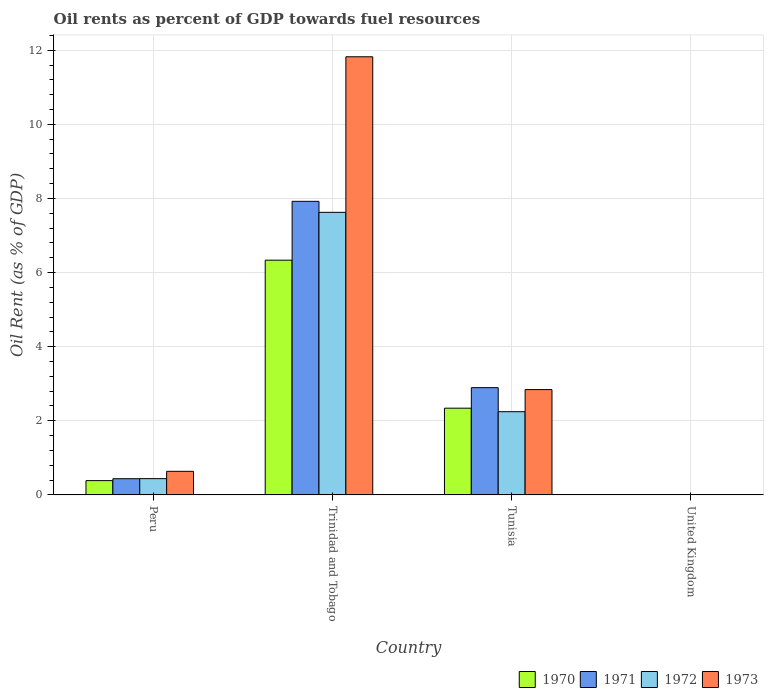How many groups of bars are there?
Offer a terse response. 4. How many bars are there on the 4th tick from the left?
Ensure brevity in your answer.  4. In how many cases, is the number of bars for a given country not equal to the number of legend labels?
Offer a very short reply. 0. What is the oil rent in 1970 in United Kingdom?
Your response must be concise. 0. Across all countries, what is the maximum oil rent in 1973?
Provide a short and direct response. 11.82. Across all countries, what is the minimum oil rent in 1971?
Give a very brief answer. 0. In which country was the oil rent in 1970 maximum?
Your response must be concise. Trinidad and Tobago. In which country was the oil rent in 1970 minimum?
Provide a short and direct response. United Kingdom. What is the total oil rent in 1973 in the graph?
Ensure brevity in your answer.  15.3. What is the difference between the oil rent in 1972 in Peru and that in United Kingdom?
Keep it short and to the point. 0.44. What is the difference between the oil rent in 1973 in Tunisia and the oil rent in 1972 in United Kingdom?
Give a very brief answer. 2.84. What is the average oil rent in 1973 per country?
Your response must be concise. 3.83. What is the difference between the oil rent of/in 1970 and oil rent of/in 1972 in United Kingdom?
Your answer should be compact. -0. What is the ratio of the oil rent in 1973 in Tunisia to that in United Kingdom?
Provide a short and direct response. 1266.39. What is the difference between the highest and the second highest oil rent in 1971?
Offer a terse response. -2.46. What is the difference between the highest and the lowest oil rent in 1972?
Your response must be concise. 7.62. In how many countries, is the oil rent in 1971 greater than the average oil rent in 1971 taken over all countries?
Give a very brief answer. 2. Is the sum of the oil rent in 1971 in Tunisia and United Kingdom greater than the maximum oil rent in 1970 across all countries?
Provide a short and direct response. No. Are all the bars in the graph horizontal?
Provide a short and direct response. No. How many countries are there in the graph?
Provide a succinct answer. 4. What is the difference between two consecutive major ticks on the Y-axis?
Make the answer very short. 2. Are the values on the major ticks of Y-axis written in scientific E-notation?
Provide a succinct answer. No. Does the graph contain any zero values?
Your response must be concise. No. What is the title of the graph?
Make the answer very short. Oil rents as percent of GDP towards fuel resources. What is the label or title of the Y-axis?
Your response must be concise. Oil Rent (as % of GDP). What is the Oil Rent (as % of GDP) in 1970 in Peru?
Keep it short and to the point. 0.39. What is the Oil Rent (as % of GDP) of 1971 in Peru?
Your response must be concise. 0.44. What is the Oil Rent (as % of GDP) of 1972 in Peru?
Offer a very short reply. 0.44. What is the Oil Rent (as % of GDP) in 1973 in Peru?
Make the answer very short. 0.64. What is the Oil Rent (as % of GDP) of 1970 in Trinidad and Tobago?
Provide a succinct answer. 6.33. What is the Oil Rent (as % of GDP) in 1971 in Trinidad and Tobago?
Keep it short and to the point. 7.92. What is the Oil Rent (as % of GDP) in 1972 in Trinidad and Tobago?
Provide a short and direct response. 7.63. What is the Oil Rent (as % of GDP) of 1973 in Trinidad and Tobago?
Keep it short and to the point. 11.82. What is the Oil Rent (as % of GDP) of 1970 in Tunisia?
Offer a very short reply. 2.34. What is the Oil Rent (as % of GDP) in 1971 in Tunisia?
Offer a terse response. 2.89. What is the Oil Rent (as % of GDP) in 1972 in Tunisia?
Offer a very short reply. 2.25. What is the Oil Rent (as % of GDP) in 1973 in Tunisia?
Keep it short and to the point. 2.84. What is the Oil Rent (as % of GDP) in 1970 in United Kingdom?
Keep it short and to the point. 0. What is the Oil Rent (as % of GDP) in 1971 in United Kingdom?
Your response must be concise. 0. What is the Oil Rent (as % of GDP) in 1972 in United Kingdom?
Ensure brevity in your answer.  0. What is the Oil Rent (as % of GDP) in 1973 in United Kingdom?
Your answer should be compact. 0. Across all countries, what is the maximum Oil Rent (as % of GDP) in 1970?
Your answer should be very brief. 6.33. Across all countries, what is the maximum Oil Rent (as % of GDP) in 1971?
Keep it short and to the point. 7.92. Across all countries, what is the maximum Oil Rent (as % of GDP) in 1972?
Offer a terse response. 7.63. Across all countries, what is the maximum Oil Rent (as % of GDP) of 1973?
Your answer should be very brief. 11.82. Across all countries, what is the minimum Oil Rent (as % of GDP) in 1970?
Keep it short and to the point. 0. Across all countries, what is the minimum Oil Rent (as % of GDP) of 1971?
Provide a short and direct response. 0. Across all countries, what is the minimum Oil Rent (as % of GDP) of 1972?
Offer a terse response. 0. Across all countries, what is the minimum Oil Rent (as % of GDP) of 1973?
Your answer should be very brief. 0. What is the total Oil Rent (as % of GDP) of 1970 in the graph?
Keep it short and to the point. 9.06. What is the total Oil Rent (as % of GDP) of 1971 in the graph?
Keep it short and to the point. 11.25. What is the total Oil Rent (as % of GDP) in 1972 in the graph?
Ensure brevity in your answer.  10.31. What is the total Oil Rent (as % of GDP) of 1973 in the graph?
Your answer should be very brief. 15.3. What is the difference between the Oil Rent (as % of GDP) of 1970 in Peru and that in Trinidad and Tobago?
Offer a terse response. -5.95. What is the difference between the Oil Rent (as % of GDP) of 1971 in Peru and that in Trinidad and Tobago?
Keep it short and to the point. -7.49. What is the difference between the Oil Rent (as % of GDP) of 1972 in Peru and that in Trinidad and Tobago?
Offer a very short reply. -7.19. What is the difference between the Oil Rent (as % of GDP) of 1973 in Peru and that in Trinidad and Tobago?
Provide a short and direct response. -11.19. What is the difference between the Oil Rent (as % of GDP) in 1970 in Peru and that in Tunisia?
Offer a very short reply. -1.95. What is the difference between the Oil Rent (as % of GDP) of 1971 in Peru and that in Tunisia?
Provide a short and direct response. -2.46. What is the difference between the Oil Rent (as % of GDP) in 1972 in Peru and that in Tunisia?
Give a very brief answer. -1.81. What is the difference between the Oil Rent (as % of GDP) in 1973 in Peru and that in Tunisia?
Your response must be concise. -2.21. What is the difference between the Oil Rent (as % of GDP) of 1970 in Peru and that in United Kingdom?
Make the answer very short. 0.38. What is the difference between the Oil Rent (as % of GDP) in 1971 in Peru and that in United Kingdom?
Offer a terse response. 0.44. What is the difference between the Oil Rent (as % of GDP) in 1972 in Peru and that in United Kingdom?
Provide a short and direct response. 0.44. What is the difference between the Oil Rent (as % of GDP) of 1973 in Peru and that in United Kingdom?
Make the answer very short. 0.63. What is the difference between the Oil Rent (as % of GDP) in 1970 in Trinidad and Tobago and that in Tunisia?
Offer a very short reply. 3.99. What is the difference between the Oil Rent (as % of GDP) in 1971 in Trinidad and Tobago and that in Tunisia?
Make the answer very short. 5.03. What is the difference between the Oil Rent (as % of GDP) of 1972 in Trinidad and Tobago and that in Tunisia?
Your answer should be very brief. 5.38. What is the difference between the Oil Rent (as % of GDP) in 1973 in Trinidad and Tobago and that in Tunisia?
Provide a short and direct response. 8.98. What is the difference between the Oil Rent (as % of GDP) in 1970 in Trinidad and Tobago and that in United Kingdom?
Your answer should be very brief. 6.33. What is the difference between the Oil Rent (as % of GDP) of 1971 in Trinidad and Tobago and that in United Kingdom?
Keep it short and to the point. 7.92. What is the difference between the Oil Rent (as % of GDP) in 1972 in Trinidad and Tobago and that in United Kingdom?
Make the answer very short. 7.62. What is the difference between the Oil Rent (as % of GDP) of 1973 in Trinidad and Tobago and that in United Kingdom?
Your answer should be compact. 11.82. What is the difference between the Oil Rent (as % of GDP) of 1970 in Tunisia and that in United Kingdom?
Offer a very short reply. 2.34. What is the difference between the Oil Rent (as % of GDP) of 1971 in Tunisia and that in United Kingdom?
Your response must be concise. 2.89. What is the difference between the Oil Rent (as % of GDP) in 1972 in Tunisia and that in United Kingdom?
Give a very brief answer. 2.24. What is the difference between the Oil Rent (as % of GDP) in 1973 in Tunisia and that in United Kingdom?
Your answer should be compact. 2.84. What is the difference between the Oil Rent (as % of GDP) in 1970 in Peru and the Oil Rent (as % of GDP) in 1971 in Trinidad and Tobago?
Your answer should be compact. -7.54. What is the difference between the Oil Rent (as % of GDP) in 1970 in Peru and the Oil Rent (as % of GDP) in 1972 in Trinidad and Tobago?
Offer a very short reply. -7.24. What is the difference between the Oil Rent (as % of GDP) in 1970 in Peru and the Oil Rent (as % of GDP) in 1973 in Trinidad and Tobago?
Ensure brevity in your answer.  -11.44. What is the difference between the Oil Rent (as % of GDP) of 1971 in Peru and the Oil Rent (as % of GDP) of 1972 in Trinidad and Tobago?
Your answer should be compact. -7.19. What is the difference between the Oil Rent (as % of GDP) in 1971 in Peru and the Oil Rent (as % of GDP) in 1973 in Trinidad and Tobago?
Give a very brief answer. -11.39. What is the difference between the Oil Rent (as % of GDP) of 1972 in Peru and the Oil Rent (as % of GDP) of 1973 in Trinidad and Tobago?
Your answer should be very brief. -11.38. What is the difference between the Oil Rent (as % of GDP) of 1970 in Peru and the Oil Rent (as % of GDP) of 1971 in Tunisia?
Your response must be concise. -2.51. What is the difference between the Oil Rent (as % of GDP) of 1970 in Peru and the Oil Rent (as % of GDP) of 1972 in Tunisia?
Your answer should be very brief. -1.86. What is the difference between the Oil Rent (as % of GDP) of 1970 in Peru and the Oil Rent (as % of GDP) of 1973 in Tunisia?
Your answer should be very brief. -2.46. What is the difference between the Oil Rent (as % of GDP) in 1971 in Peru and the Oil Rent (as % of GDP) in 1972 in Tunisia?
Offer a very short reply. -1.81. What is the difference between the Oil Rent (as % of GDP) in 1971 in Peru and the Oil Rent (as % of GDP) in 1973 in Tunisia?
Offer a terse response. -2.4. What is the difference between the Oil Rent (as % of GDP) of 1972 in Peru and the Oil Rent (as % of GDP) of 1973 in Tunisia?
Offer a very short reply. -2.4. What is the difference between the Oil Rent (as % of GDP) in 1970 in Peru and the Oil Rent (as % of GDP) in 1971 in United Kingdom?
Provide a succinct answer. 0.38. What is the difference between the Oil Rent (as % of GDP) in 1970 in Peru and the Oil Rent (as % of GDP) in 1972 in United Kingdom?
Make the answer very short. 0.38. What is the difference between the Oil Rent (as % of GDP) in 1970 in Peru and the Oil Rent (as % of GDP) in 1973 in United Kingdom?
Make the answer very short. 0.38. What is the difference between the Oil Rent (as % of GDP) in 1971 in Peru and the Oil Rent (as % of GDP) in 1972 in United Kingdom?
Offer a very short reply. 0.44. What is the difference between the Oil Rent (as % of GDP) in 1971 in Peru and the Oil Rent (as % of GDP) in 1973 in United Kingdom?
Offer a very short reply. 0.43. What is the difference between the Oil Rent (as % of GDP) of 1972 in Peru and the Oil Rent (as % of GDP) of 1973 in United Kingdom?
Keep it short and to the point. 0.44. What is the difference between the Oil Rent (as % of GDP) in 1970 in Trinidad and Tobago and the Oil Rent (as % of GDP) in 1971 in Tunisia?
Give a very brief answer. 3.44. What is the difference between the Oil Rent (as % of GDP) in 1970 in Trinidad and Tobago and the Oil Rent (as % of GDP) in 1972 in Tunisia?
Provide a succinct answer. 4.09. What is the difference between the Oil Rent (as % of GDP) in 1970 in Trinidad and Tobago and the Oil Rent (as % of GDP) in 1973 in Tunisia?
Your answer should be very brief. 3.49. What is the difference between the Oil Rent (as % of GDP) of 1971 in Trinidad and Tobago and the Oil Rent (as % of GDP) of 1972 in Tunisia?
Offer a terse response. 5.68. What is the difference between the Oil Rent (as % of GDP) of 1971 in Trinidad and Tobago and the Oil Rent (as % of GDP) of 1973 in Tunisia?
Make the answer very short. 5.08. What is the difference between the Oil Rent (as % of GDP) of 1972 in Trinidad and Tobago and the Oil Rent (as % of GDP) of 1973 in Tunisia?
Your response must be concise. 4.78. What is the difference between the Oil Rent (as % of GDP) in 1970 in Trinidad and Tobago and the Oil Rent (as % of GDP) in 1971 in United Kingdom?
Your answer should be compact. 6.33. What is the difference between the Oil Rent (as % of GDP) of 1970 in Trinidad and Tobago and the Oil Rent (as % of GDP) of 1972 in United Kingdom?
Offer a terse response. 6.33. What is the difference between the Oil Rent (as % of GDP) in 1970 in Trinidad and Tobago and the Oil Rent (as % of GDP) in 1973 in United Kingdom?
Your answer should be compact. 6.33. What is the difference between the Oil Rent (as % of GDP) of 1971 in Trinidad and Tobago and the Oil Rent (as % of GDP) of 1972 in United Kingdom?
Keep it short and to the point. 7.92. What is the difference between the Oil Rent (as % of GDP) in 1971 in Trinidad and Tobago and the Oil Rent (as % of GDP) in 1973 in United Kingdom?
Make the answer very short. 7.92. What is the difference between the Oil Rent (as % of GDP) in 1972 in Trinidad and Tobago and the Oil Rent (as % of GDP) in 1973 in United Kingdom?
Provide a succinct answer. 7.62. What is the difference between the Oil Rent (as % of GDP) in 1970 in Tunisia and the Oil Rent (as % of GDP) in 1971 in United Kingdom?
Provide a succinct answer. 2.34. What is the difference between the Oil Rent (as % of GDP) in 1970 in Tunisia and the Oil Rent (as % of GDP) in 1972 in United Kingdom?
Ensure brevity in your answer.  2.34. What is the difference between the Oil Rent (as % of GDP) in 1970 in Tunisia and the Oil Rent (as % of GDP) in 1973 in United Kingdom?
Make the answer very short. 2.34. What is the difference between the Oil Rent (as % of GDP) in 1971 in Tunisia and the Oil Rent (as % of GDP) in 1972 in United Kingdom?
Your answer should be compact. 2.89. What is the difference between the Oil Rent (as % of GDP) in 1971 in Tunisia and the Oil Rent (as % of GDP) in 1973 in United Kingdom?
Offer a very short reply. 2.89. What is the difference between the Oil Rent (as % of GDP) of 1972 in Tunisia and the Oil Rent (as % of GDP) of 1973 in United Kingdom?
Keep it short and to the point. 2.24. What is the average Oil Rent (as % of GDP) in 1970 per country?
Your answer should be compact. 2.27. What is the average Oil Rent (as % of GDP) of 1971 per country?
Your answer should be compact. 2.81. What is the average Oil Rent (as % of GDP) in 1972 per country?
Offer a very short reply. 2.58. What is the average Oil Rent (as % of GDP) in 1973 per country?
Your response must be concise. 3.83. What is the difference between the Oil Rent (as % of GDP) in 1970 and Oil Rent (as % of GDP) in 1971 in Peru?
Ensure brevity in your answer.  -0.05. What is the difference between the Oil Rent (as % of GDP) of 1970 and Oil Rent (as % of GDP) of 1972 in Peru?
Keep it short and to the point. -0.05. What is the difference between the Oil Rent (as % of GDP) in 1970 and Oil Rent (as % of GDP) in 1973 in Peru?
Offer a very short reply. -0.25. What is the difference between the Oil Rent (as % of GDP) in 1971 and Oil Rent (as % of GDP) in 1972 in Peru?
Ensure brevity in your answer.  -0. What is the difference between the Oil Rent (as % of GDP) in 1971 and Oil Rent (as % of GDP) in 1973 in Peru?
Make the answer very short. -0.2. What is the difference between the Oil Rent (as % of GDP) of 1972 and Oil Rent (as % of GDP) of 1973 in Peru?
Make the answer very short. -0.2. What is the difference between the Oil Rent (as % of GDP) in 1970 and Oil Rent (as % of GDP) in 1971 in Trinidad and Tobago?
Keep it short and to the point. -1.59. What is the difference between the Oil Rent (as % of GDP) of 1970 and Oil Rent (as % of GDP) of 1972 in Trinidad and Tobago?
Offer a very short reply. -1.29. What is the difference between the Oil Rent (as % of GDP) in 1970 and Oil Rent (as % of GDP) in 1973 in Trinidad and Tobago?
Provide a short and direct response. -5.49. What is the difference between the Oil Rent (as % of GDP) of 1971 and Oil Rent (as % of GDP) of 1972 in Trinidad and Tobago?
Offer a terse response. 0.3. What is the difference between the Oil Rent (as % of GDP) of 1971 and Oil Rent (as % of GDP) of 1973 in Trinidad and Tobago?
Your answer should be very brief. -3.9. What is the difference between the Oil Rent (as % of GDP) in 1972 and Oil Rent (as % of GDP) in 1973 in Trinidad and Tobago?
Give a very brief answer. -4.2. What is the difference between the Oil Rent (as % of GDP) of 1970 and Oil Rent (as % of GDP) of 1971 in Tunisia?
Your answer should be compact. -0.55. What is the difference between the Oil Rent (as % of GDP) in 1970 and Oil Rent (as % of GDP) in 1972 in Tunisia?
Offer a very short reply. 0.1. What is the difference between the Oil Rent (as % of GDP) in 1970 and Oil Rent (as % of GDP) in 1973 in Tunisia?
Your answer should be very brief. -0.5. What is the difference between the Oil Rent (as % of GDP) of 1971 and Oil Rent (as % of GDP) of 1972 in Tunisia?
Keep it short and to the point. 0.65. What is the difference between the Oil Rent (as % of GDP) of 1971 and Oil Rent (as % of GDP) of 1973 in Tunisia?
Provide a succinct answer. 0.05. What is the difference between the Oil Rent (as % of GDP) in 1972 and Oil Rent (as % of GDP) in 1973 in Tunisia?
Your answer should be very brief. -0.6. What is the difference between the Oil Rent (as % of GDP) in 1970 and Oil Rent (as % of GDP) in 1971 in United Kingdom?
Provide a succinct answer. 0. What is the difference between the Oil Rent (as % of GDP) of 1970 and Oil Rent (as % of GDP) of 1972 in United Kingdom?
Provide a short and direct response. -0. What is the difference between the Oil Rent (as % of GDP) in 1970 and Oil Rent (as % of GDP) in 1973 in United Kingdom?
Your answer should be very brief. -0. What is the difference between the Oil Rent (as % of GDP) in 1971 and Oil Rent (as % of GDP) in 1972 in United Kingdom?
Ensure brevity in your answer.  -0. What is the difference between the Oil Rent (as % of GDP) in 1971 and Oil Rent (as % of GDP) in 1973 in United Kingdom?
Provide a short and direct response. -0. What is the difference between the Oil Rent (as % of GDP) of 1972 and Oil Rent (as % of GDP) of 1973 in United Kingdom?
Make the answer very short. -0. What is the ratio of the Oil Rent (as % of GDP) of 1970 in Peru to that in Trinidad and Tobago?
Make the answer very short. 0.06. What is the ratio of the Oil Rent (as % of GDP) of 1971 in Peru to that in Trinidad and Tobago?
Your response must be concise. 0.06. What is the ratio of the Oil Rent (as % of GDP) in 1972 in Peru to that in Trinidad and Tobago?
Your response must be concise. 0.06. What is the ratio of the Oil Rent (as % of GDP) of 1973 in Peru to that in Trinidad and Tobago?
Offer a very short reply. 0.05. What is the ratio of the Oil Rent (as % of GDP) of 1970 in Peru to that in Tunisia?
Make the answer very short. 0.16. What is the ratio of the Oil Rent (as % of GDP) in 1971 in Peru to that in Tunisia?
Your response must be concise. 0.15. What is the ratio of the Oil Rent (as % of GDP) of 1972 in Peru to that in Tunisia?
Offer a terse response. 0.2. What is the ratio of the Oil Rent (as % of GDP) in 1973 in Peru to that in Tunisia?
Make the answer very short. 0.22. What is the ratio of the Oil Rent (as % of GDP) of 1970 in Peru to that in United Kingdom?
Your answer should be compact. 435.22. What is the ratio of the Oil Rent (as % of GDP) of 1971 in Peru to that in United Kingdom?
Offer a terse response. 617.08. What is the ratio of the Oil Rent (as % of GDP) in 1972 in Peru to that in United Kingdom?
Offer a terse response. 339.21. What is the ratio of the Oil Rent (as % of GDP) of 1973 in Peru to that in United Kingdom?
Your answer should be very brief. 283.34. What is the ratio of the Oil Rent (as % of GDP) in 1970 in Trinidad and Tobago to that in Tunisia?
Make the answer very short. 2.71. What is the ratio of the Oil Rent (as % of GDP) in 1971 in Trinidad and Tobago to that in Tunisia?
Your answer should be very brief. 2.74. What is the ratio of the Oil Rent (as % of GDP) in 1972 in Trinidad and Tobago to that in Tunisia?
Provide a succinct answer. 3.4. What is the ratio of the Oil Rent (as % of GDP) in 1973 in Trinidad and Tobago to that in Tunisia?
Your answer should be very brief. 4.16. What is the ratio of the Oil Rent (as % of GDP) of 1970 in Trinidad and Tobago to that in United Kingdom?
Your answer should be compact. 7151.98. What is the ratio of the Oil Rent (as % of GDP) of 1971 in Trinidad and Tobago to that in United Kingdom?
Ensure brevity in your answer.  1.12e+04. What is the ratio of the Oil Rent (as % of GDP) of 1972 in Trinidad and Tobago to that in United Kingdom?
Provide a succinct answer. 5894.4. What is the ratio of the Oil Rent (as % of GDP) in 1973 in Trinidad and Tobago to that in United Kingdom?
Your answer should be very brief. 5268.85. What is the ratio of the Oil Rent (as % of GDP) of 1970 in Tunisia to that in United Kingdom?
Make the answer very short. 2642.42. What is the ratio of the Oil Rent (as % of GDP) in 1971 in Tunisia to that in United Kingdom?
Your answer should be very brief. 4088.61. What is the ratio of the Oil Rent (as % of GDP) of 1972 in Tunisia to that in United Kingdom?
Give a very brief answer. 1735.44. What is the ratio of the Oil Rent (as % of GDP) of 1973 in Tunisia to that in United Kingdom?
Your answer should be very brief. 1266.39. What is the difference between the highest and the second highest Oil Rent (as % of GDP) in 1970?
Your answer should be compact. 3.99. What is the difference between the highest and the second highest Oil Rent (as % of GDP) of 1971?
Keep it short and to the point. 5.03. What is the difference between the highest and the second highest Oil Rent (as % of GDP) of 1972?
Your answer should be compact. 5.38. What is the difference between the highest and the second highest Oil Rent (as % of GDP) of 1973?
Ensure brevity in your answer.  8.98. What is the difference between the highest and the lowest Oil Rent (as % of GDP) in 1970?
Your response must be concise. 6.33. What is the difference between the highest and the lowest Oil Rent (as % of GDP) in 1971?
Give a very brief answer. 7.92. What is the difference between the highest and the lowest Oil Rent (as % of GDP) in 1972?
Provide a succinct answer. 7.62. What is the difference between the highest and the lowest Oil Rent (as % of GDP) of 1973?
Your answer should be very brief. 11.82. 